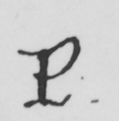Transcribe the text shown in this historical manuscript line. P . 